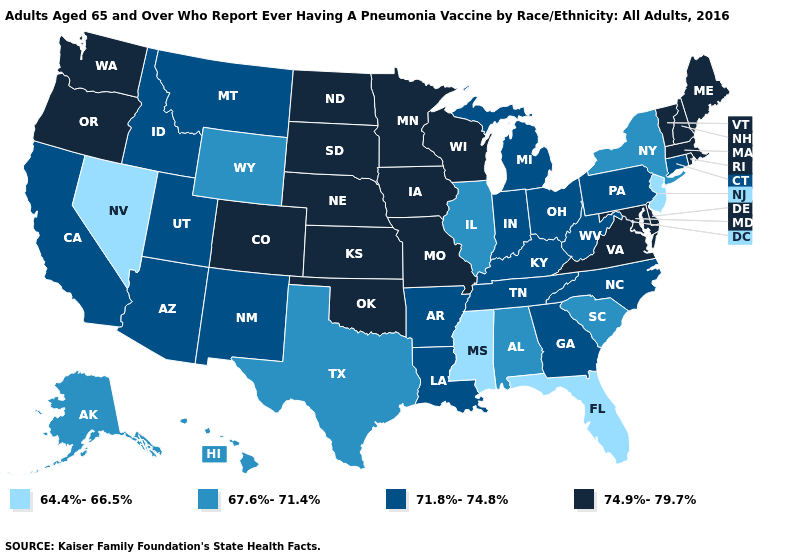Does Hawaii have the highest value in the West?
Short answer required. No. Which states have the lowest value in the USA?
Be succinct. Florida, Mississippi, Nevada, New Jersey. Does Georgia have the highest value in the South?
Give a very brief answer. No. Does the map have missing data?
Write a very short answer. No. Name the states that have a value in the range 74.9%-79.7%?
Concise answer only. Colorado, Delaware, Iowa, Kansas, Maine, Maryland, Massachusetts, Minnesota, Missouri, Nebraska, New Hampshire, North Dakota, Oklahoma, Oregon, Rhode Island, South Dakota, Vermont, Virginia, Washington, Wisconsin. What is the value of Alabama?
Concise answer only. 67.6%-71.4%. What is the value of South Carolina?
Keep it brief. 67.6%-71.4%. Which states have the lowest value in the USA?
Write a very short answer. Florida, Mississippi, Nevada, New Jersey. Among the states that border Nevada , which have the lowest value?
Concise answer only. Arizona, California, Idaho, Utah. Name the states that have a value in the range 64.4%-66.5%?
Quick response, please. Florida, Mississippi, Nevada, New Jersey. Does Colorado have the highest value in the West?
Write a very short answer. Yes. Name the states that have a value in the range 67.6%-71.4%?
Short answer required. Alabama, Alaska, Hawaii, Illinois, New York, South Carolina, Texas, Wyoming. Which states have the highest value in the USA?
Keep it brief. Colorado, Delaware, Iowa, Kansas, Maine, Maryland, Massachusetts, Minnesota, Missouri, Nebraska, New Hampshire, North Dakota, Oklahoma, Oregon, Rhode Island, South Dakota, Vermont, Virginia, Washington, Wisconsin. What is the highest value in the Northeast ?
Quick response, please. 74.9%-79.7%. What is the value of Michigan?
Short answer required. 71.8%-74.8%. 